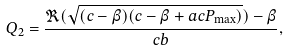<formula> <loc_0><loc_0><loc_500><loc_500>Q _ { 2 } = \frac { \Re ( \sqrt { ( c - \beta ) ( c - \beta + a c P _ { \max } ) } ) - \beta } { c b } ,</formula> 